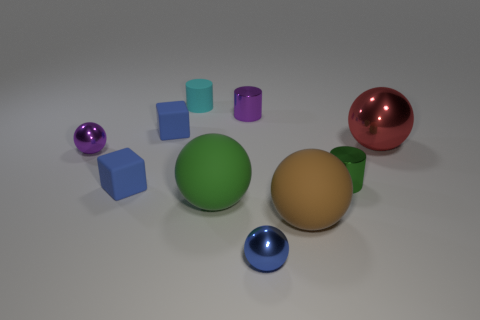What shape is the blue metal thing that is the same size as the cyan matte cylinder?
Offer a terse response. Sphere. What shape is the large shiny object?
Provide a succinct answer. Sphere. Are the blue object in front of the large brown rubber sphere and the tiny cyan cylinder made of the same material?
Your answer should be very brief. No. What is the size of the green ball that is to the left of the metallic cylinder in front of the small purple ball?
Your answer should be very brief. Large. There is a large ball that is both on the right side of the big green matte ball and to the left of the red sphere; what is its color?
Your answer should be compact. Brown. There is a blue sphere that is the same size as the green shiny cylinder; what is its material?
Ensure brevity in your answer.  Metal. How many other things are the same material as the large brown ball?
Give a very brief answer. 4. Does the tiny matte block that is in front of the purple ball have the same color as the tiny ball that is on the right side of the large green thing?
Provide a succinct answer. Yes. The blue thing behind the tiny purple metal ball left of the cyan thing is what shape?
Provide a short and direct response. Cube. What number of other objects are the same color as the tiny rubber cylinder?
Provide a succinct answer. 0. 